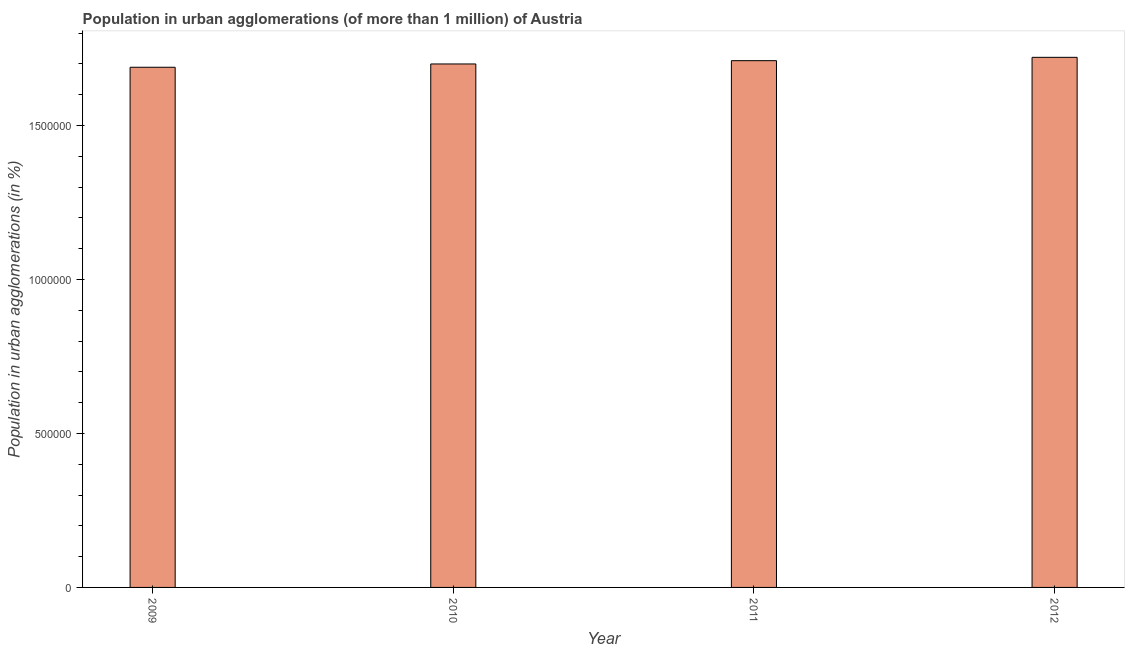Does the graph contain any zero values?
Give a very brief answer. No. Does the graph contain grids?
Your response must be concise. No. What is the title of the graph?
Your response must be concise. Population in urban agglomerations (of more than 1 million) of Austria. What is the label or title of the X-axis?
Your answer should be compact. Year. What is the label or title of the Y-axis?
Your answer should be compact. Population in urban agglomerations (in %). What is the population in urban agglomerations in 2011?
Your response must be concise. 1.71e+06. Across all years, what is the maximum population in urban agglomerations?
Provide a succinct answer. 1.72e+06. Across all years, what is the minimum population in urban agglomerations?
Offer a very short reply. 1.69e+06. In which year was the population in urban agglomerations maximum?
Make the answer very short. 2012. What is the sum of the population in urban agglomerations?
Your answer should be very brief. 6.82e+06. What is the difference between the population in urban agglomerations in 2009 and 2011?
Offer a very short reply. -2.14e+04. What is the average population in urban agglomerations per year?
Keep it short and to the point. 1.71e+06. What is the median population in urban agglomerations?
Provide a succinct answer. 1.71e+06. In how many years, is the population in urban agglomerations greater than 1500000 %?
Your response must be concise. 4. Do a majority of the years between 2011 and 2012 (inclusive) have population in urban agglomerations greater than 1200000 %?
Offer a very short reply. Yes. What is the ratio of the population in urban agglomerations in 2010 to that in 2011?
Offer a very short reply. 0.99. What is the difference between the highest and the second highest population in urban agglomerations?
Provide a succinct answer. 1.08e+04. Is the sum of the population in urban agglomerations in 2011 and 2012 greater than the maximum population in urban agglomerations across all years?
Keep it short and to the point. Yes. What is the difference between the highest and the lowest population in urban agglomerations?
Provide a short and direct response. 3.22e+04. How many bars are there?
Offer a terse response. 4. Are the values on the major ticks of Y-axis written in scientific E-notation?
Your response must be concise. No. What is the Population in urban agglomerations (in %) in 2009?
Your answer should be compact. 1.69e+06. What is the Population in urban agglomerations (in %) of 2010?
Your answer should be compact. 1.70e+06. What is the Population in urban agglomerations (in %) of 2011?
Keep it short and to the point. 1.71e+06. What is the Population in urban agglomerations (in %) in 2012?
Your response must be concise. 1.72e+06. What is the difference between the Population in urban agglomerations (in %) in 2009 and 2010?
Offer a very short reply. -1.07e+04. What is the difference between the Population in urban agglomerations (in %) in 2009 and 2011?
Your response must be concise. -2.14e+04. What is the difference between the Population in urban agglomerations (in %) in 2009 and 2012?
Offer a terse response. -3.22e+04. What is the difference between the Population in urban agglomerations (in %) in 2010 and 2011?
Provide a short and direct response. -1.07e+04. What is the difference between the Population in urban agglomerations (in %) in 2010 and 2012?
Keep it short and to the point. -2.16e+04. What is the difference between the Population in urban agglomerations (in %) in 2011 and 2012?
Your answer should be compact. -1.08e+04. 